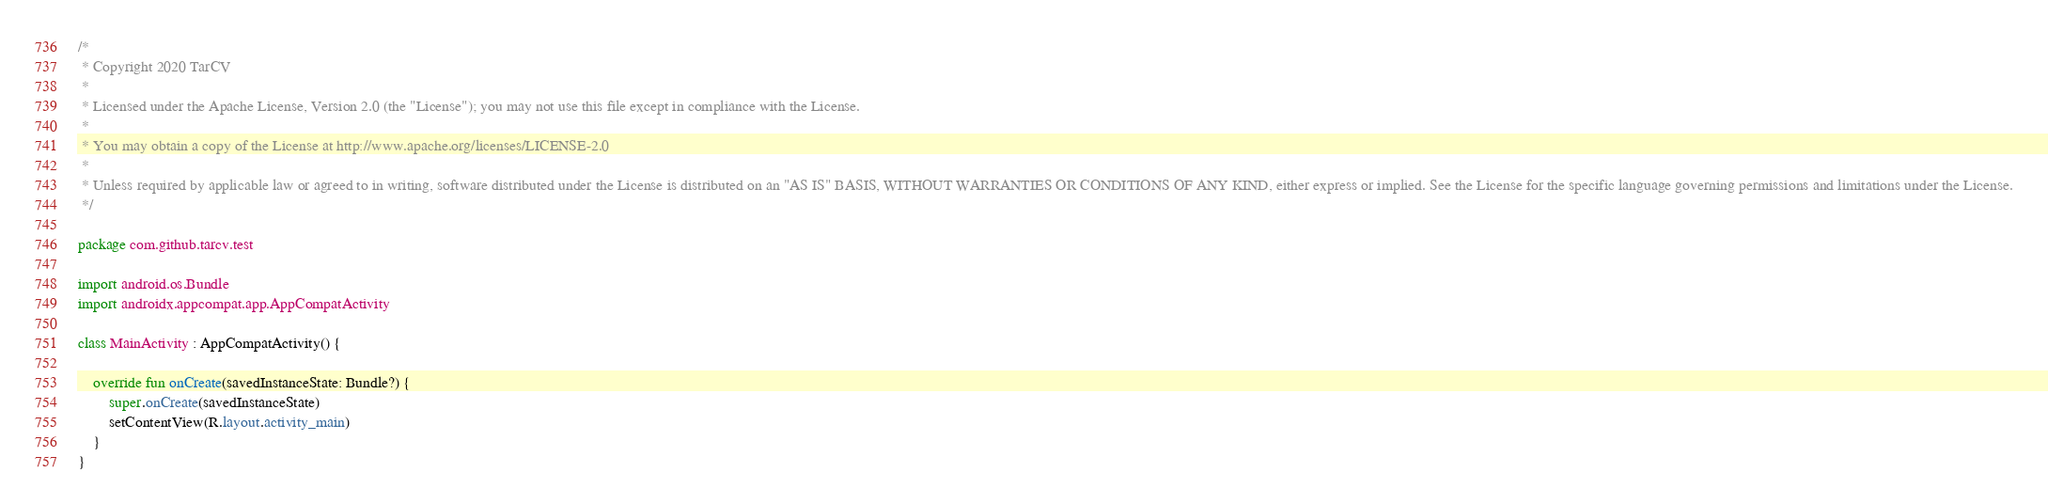<code> <loc_0><loc_0><loc_500><loc_500><_Kotlin_>/*
 * Copyright 2020 TarCV
 *
 * Licensed under the Apache License, Version 2.0 (the "License"); you may not use this file except in compliance with the License.
 *
 * You may obtain a copy of the License at http://www.apache.org/licenses/LICENSE-2.0
 *
 * Unless required by applicable law or agreed to in writing, software distributed under the License is distributed on an "AS IS" BASIS, WITHOUT WARRANTIES OR CONDITIONS OF ANY KIND, either express or implied. See the License for the specific language governing permissions and limitations under the License.
 */

package com.github.tarcv.test

import android.os.Bundle
import androidx.appcompat.app.AppCompatActivity

class MainActivity : AppCompatActivity() {

    override fun onCreate(savedInstanceState: Bundle?) {
        super.onCreate(savedInstanceState)
        setContentView(R.layout.activity_main)
    }
}</code> 